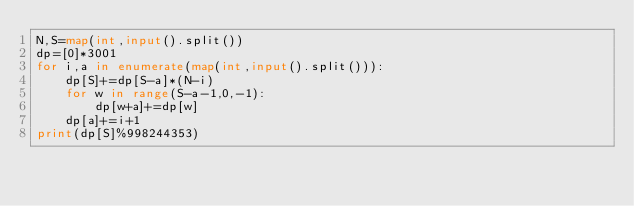<code> <loc_0><loc_0><loc_500><loc_500><_Python_>N,S=map(int,input().split())
dp=[0]*3001
for i,a in enumerate(map(int,input().split())):
    dp[S]+=dp[S-a]*(N-i)
    for w in range(S-a-1,0,-1):
        dp[w+a]+=dp[w]
    dp[a]+=i+1
print(dp[S]%998244353)</code> 